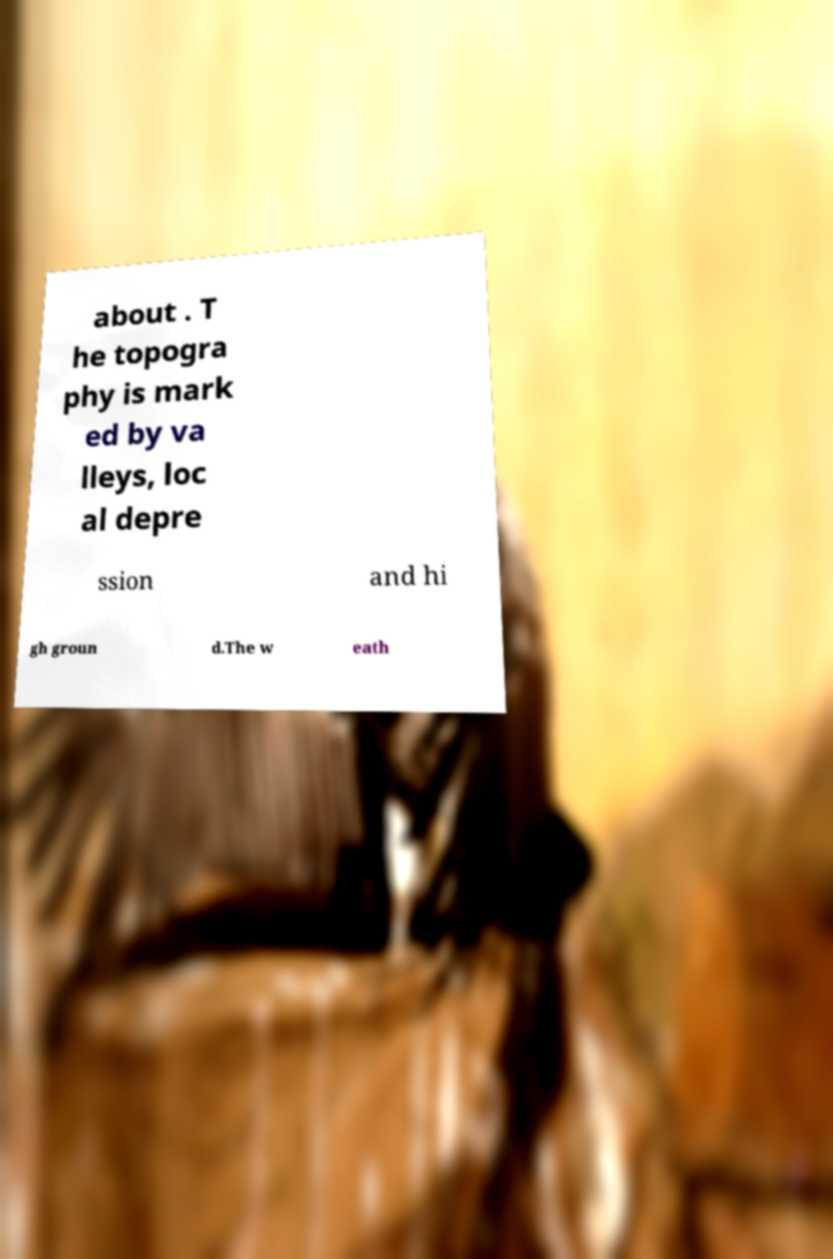Could you assist in decoding the text presented in this image and type it out clearly? about . T he topogra phy is mark ed by va lleys, loc al depre ssion and hi gh groun d.The w eath 